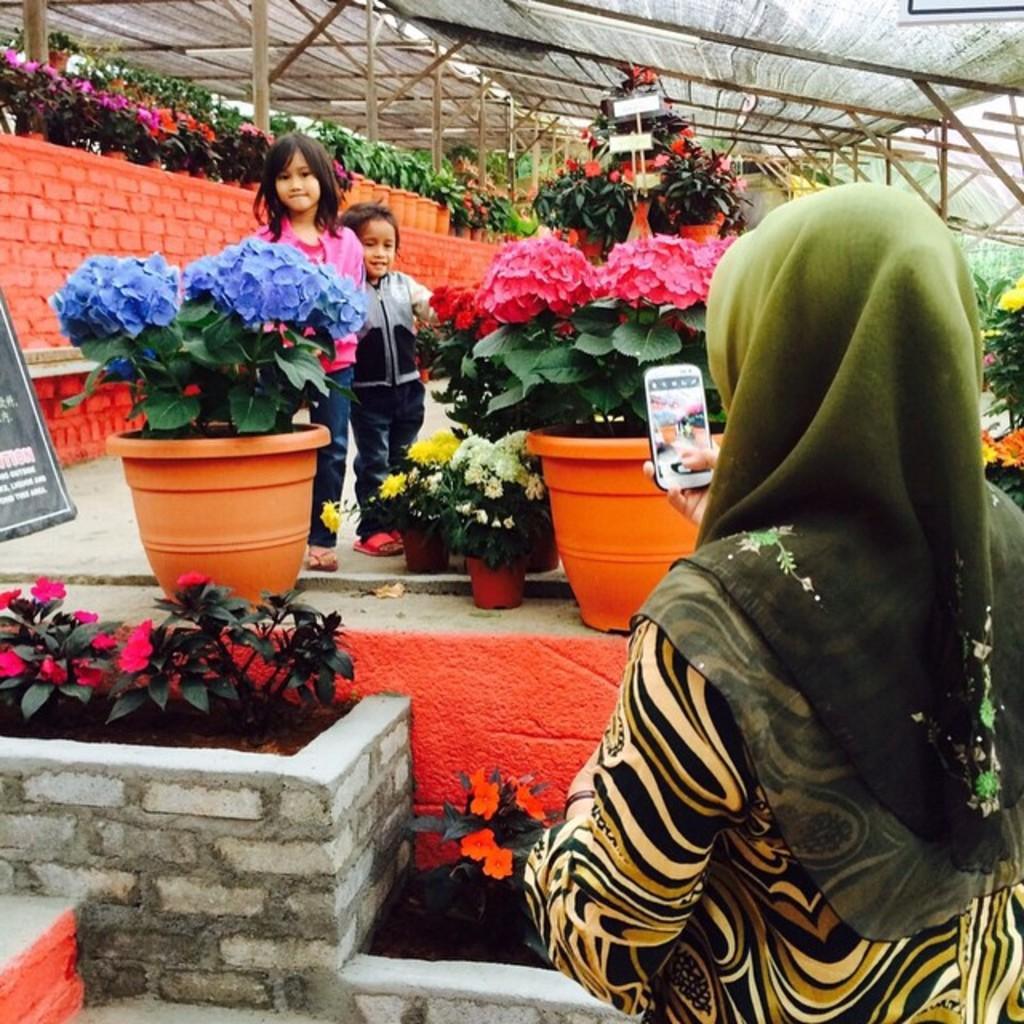Describe this image in one or two sentences. On the right side of the image there is a lady standing and holding the mobile in her hand. In front of her there are plants which are in pink color. In front of them there are few spots with white, yellow, pink and violet color flowers. Behind them there are two kids standing. In the background there are many pots with plants and flowers. Also there are wooden logs, at the top of the image there is a roof. On the left side of the image there is a black poster. 